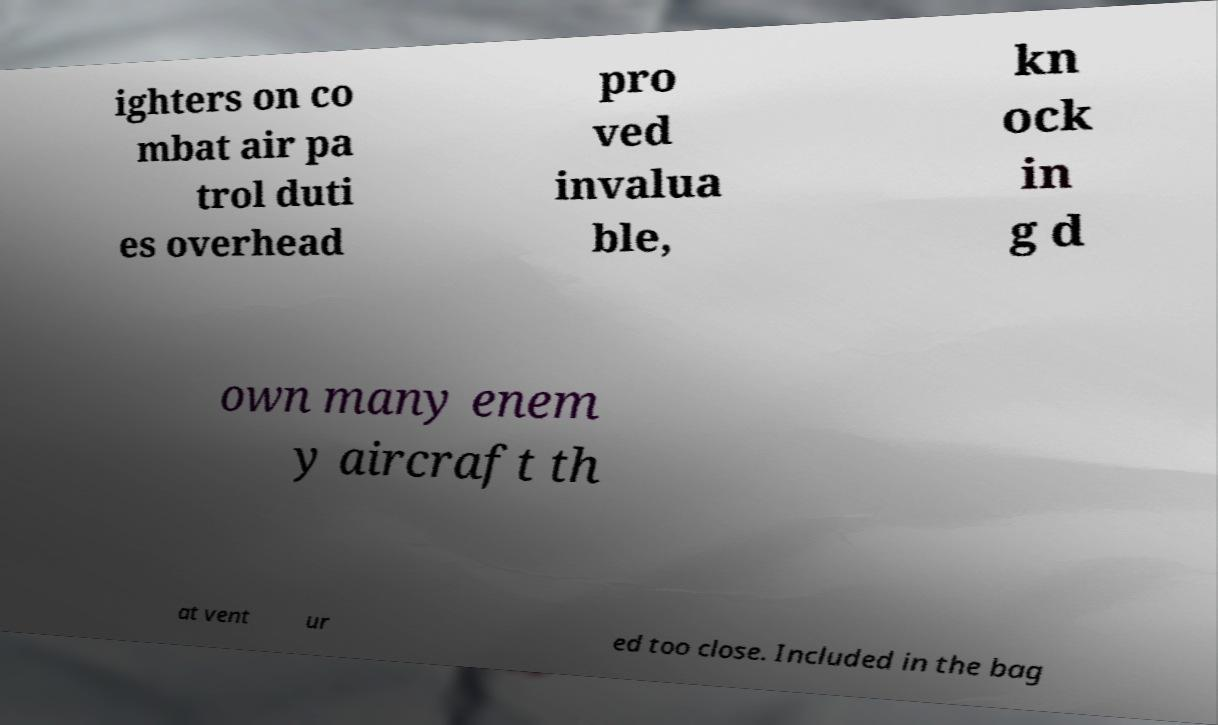What messages or text are displayed in this image? I need them in a readable, typed format. ighters on co mbat air pa trol duti es overhead pro ved invalua ble, kn ock in g d own many enem y aircraft th at vent ur ed too close. Included in the bag 